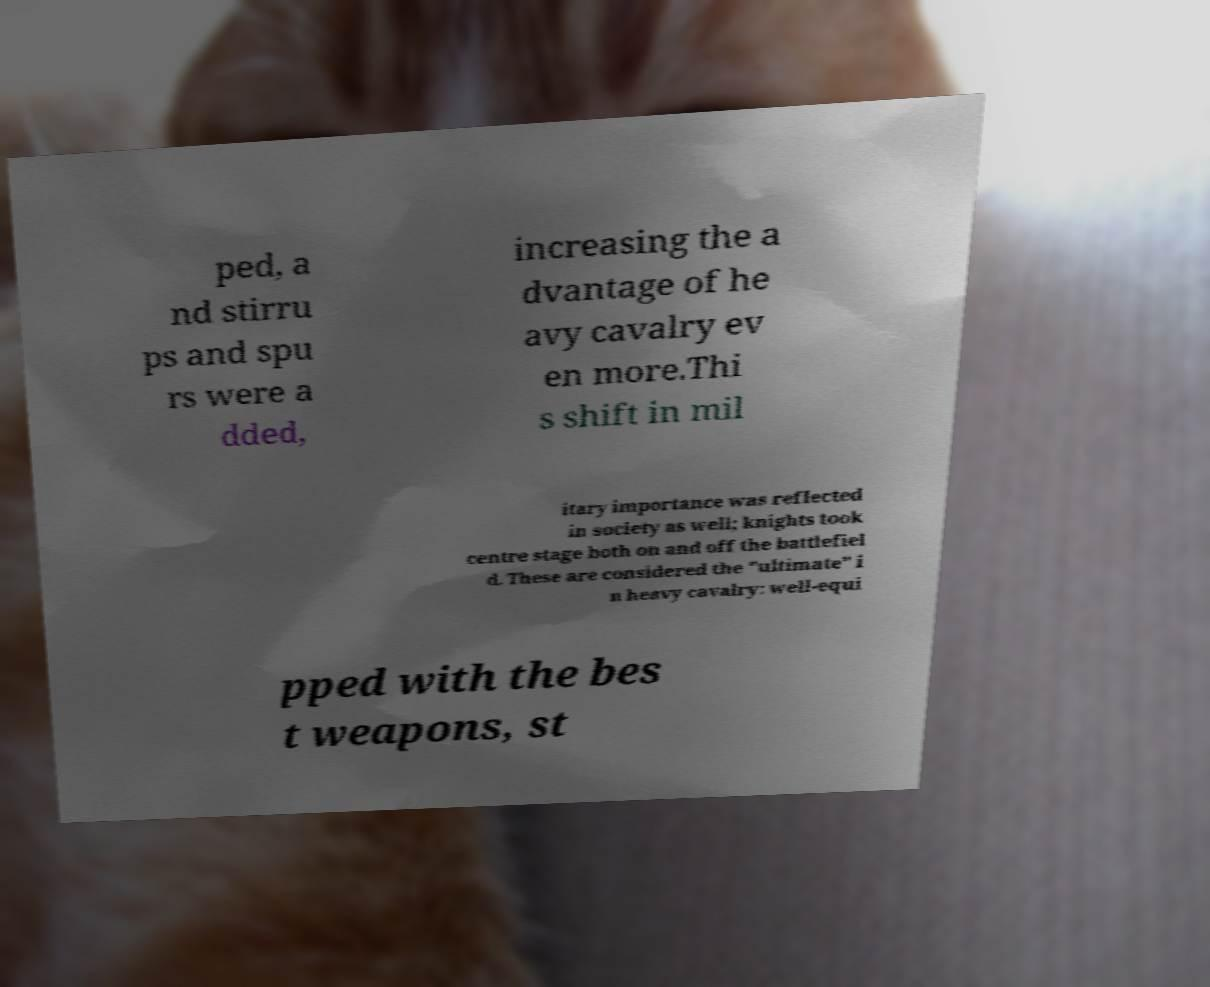Please identify and transcribe the text found in this image. ped, a nd stirru ps and spu rs were a dded, increasing the a dvantage of he avy cavalry ev en more.Thi s shift in mil itary importance was reflected in society as well; knights took centre stage both on and off the battlefiel d. These are considered the "ultimate" i n heavy cavalry: well-equi pped with the bes t weapons, st 